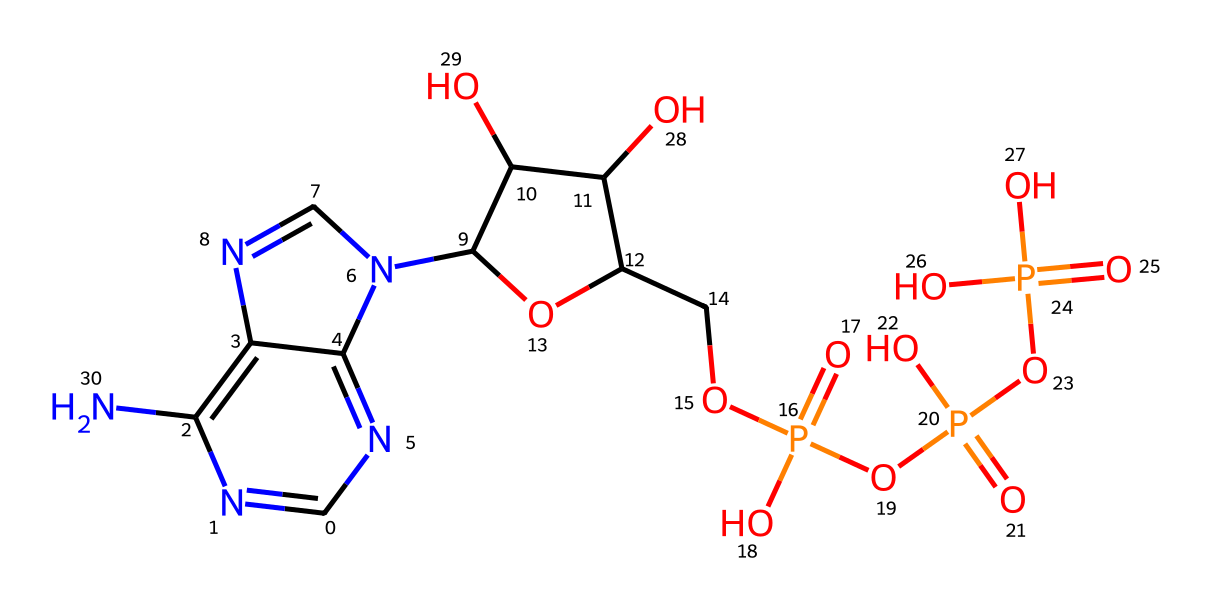What is the molecular formula of ATP? By analyzing the SMILES representation, the total number of carbon (C), hydrogen (H), nitrogen (N), oxygen (O), and phosphorus (P) atoms can be counted. The molecular formula can be derived as C10H13N5O13P3.
Answer: C10H13N5O13P3 How many phosphate groups are present in ATP? In the SMILES, there are three occurrences of the phosphoric acid group (P(=O)(O)O), indicating the presence of three phosphate groups.
Answer: 3 What kind of compound is ATP classified as? ATP contains multiple phosphate groups and is known as a nucleotide, which is characterized by a nitrogenous base, a sugar, and phosphate groups.
Answer: nucleotide What is the function of ATP in cells? ATP serves as an energy currency in cells, providing energy for various biochemical processes.
Answer: energy Which atom in ATP contributes to the structure of the phosphoanhydride bond? The phosphorus atom (P) is central to forming the phosphoanhydride bonds between the phosphate groups which store energy.
Answer: phosphorus How many nitrogen atoms are present in ATP? The SMILES indicates there are five nitrogen (N) atoms evident in the structure, confirming their count.
Answer: 5 What type of functional groups are represented in ATP? The presence of hydroxyl (OH) groups, phosphate (PO4), and amine (NH) groups can be noted, indicating multiple functional groups.
Answer: hydroxyl, phosphate, amine 